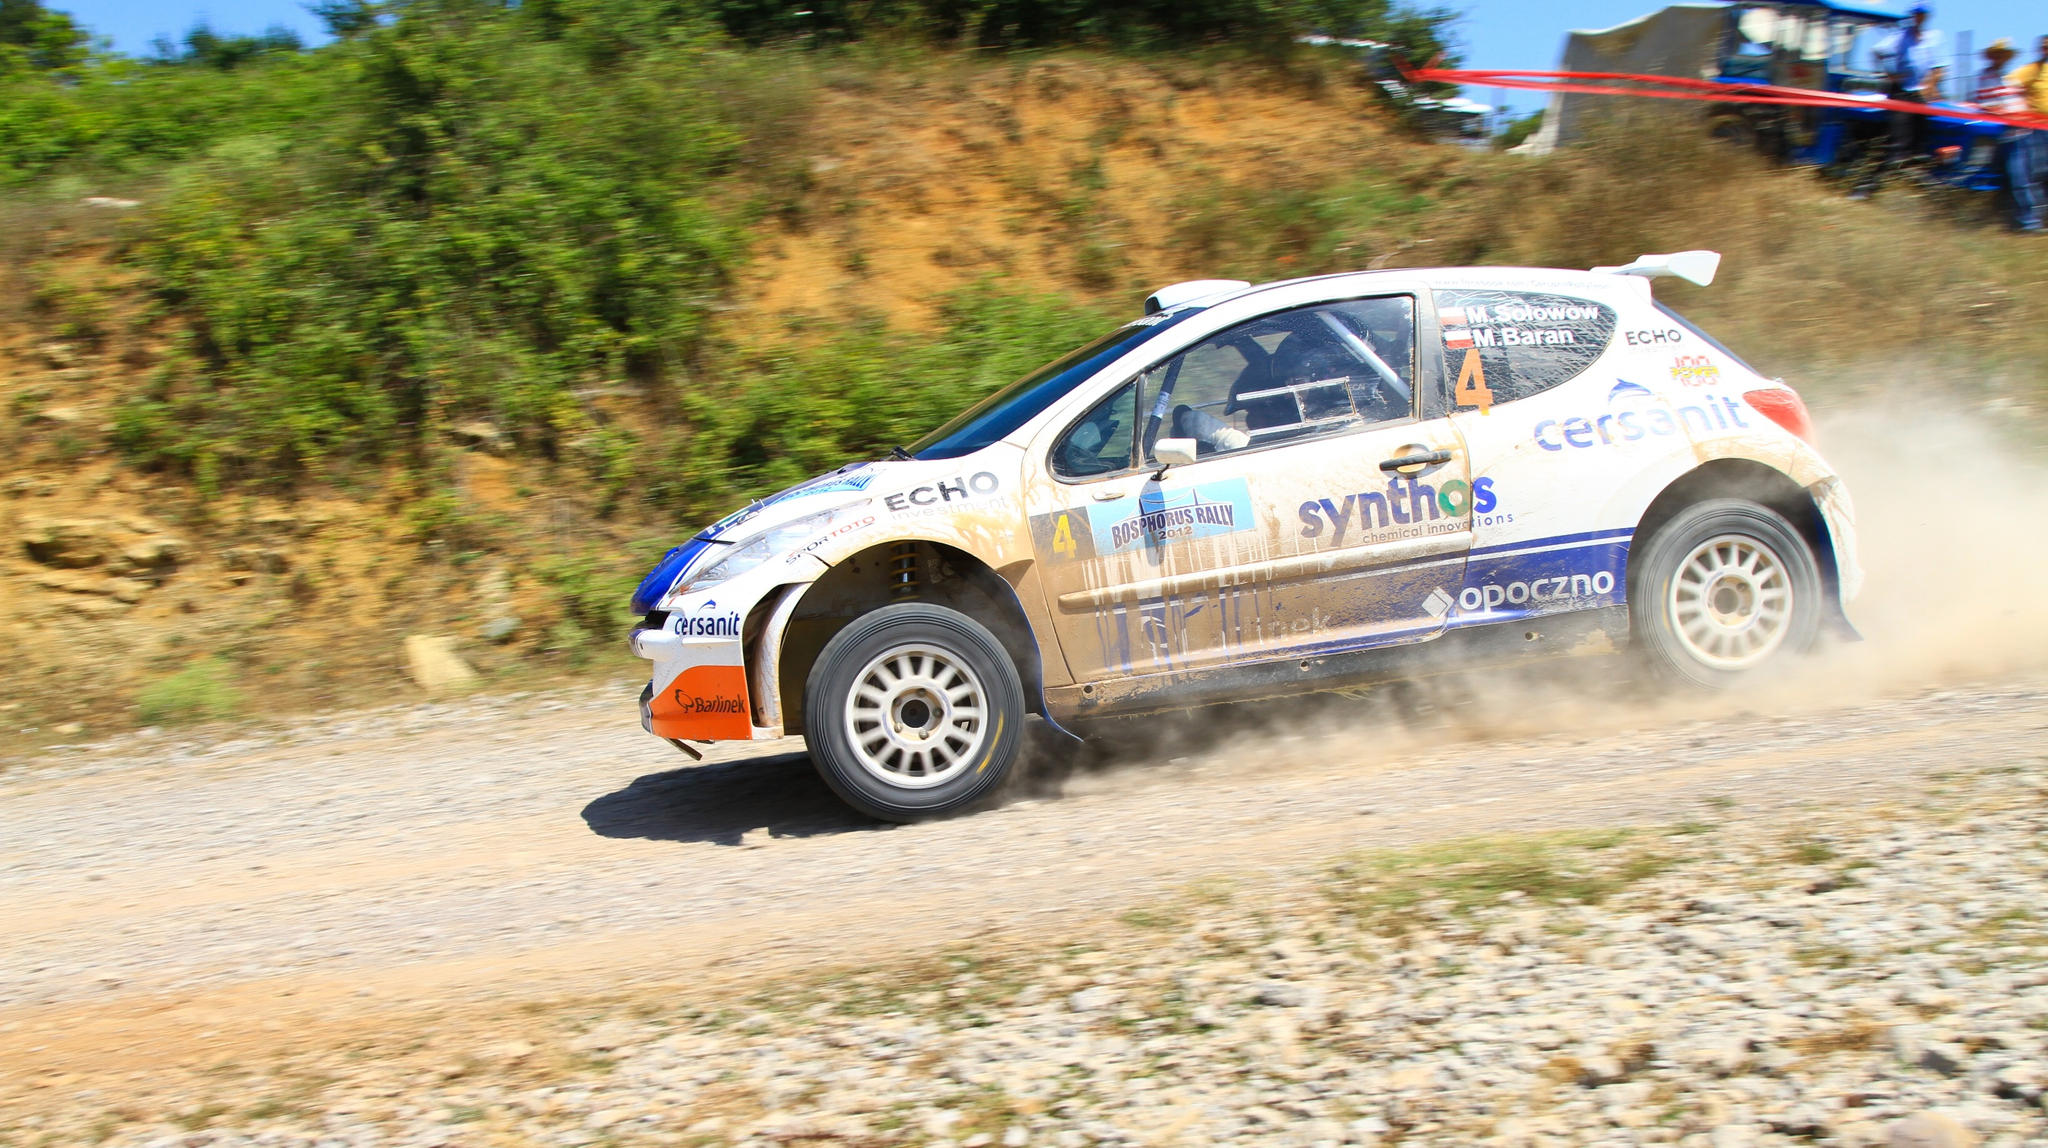What do you think is going on in this snapshot?
 The image captures a dynamic scene of a rally car race. A white hatchback car, adorned with blue and orange decals, is in motion on a dirt road. The car is stirring up a cloud of dust behind it, indicating its high speed. The decals on the car include the words "synthos", "cersanit", and "opoczno". 

The car is equipped with a spoiler on the back, a common feature in rally cars for aerodynamic purposes. The car is moving towards the right side of the image, suggesting it's taking a turn or maneuvering on the track.

The backdrop of the image is a serene outdoor setting. There's a hill visible in the distance, and trees line the road on which the car is driving. The sky above is clear and blue, suggesting it's a sunny day. The car, the road, and the surrounding nature create a vivid scene of a rally car race in progress. 